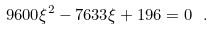<formula> <loc_0><loc_0><loc_500><loc_500>9 6 0 0 \xi ^ { 2 } - 7 6 3 3 \xi + 1 9 6 = 0 \ .</formula> 